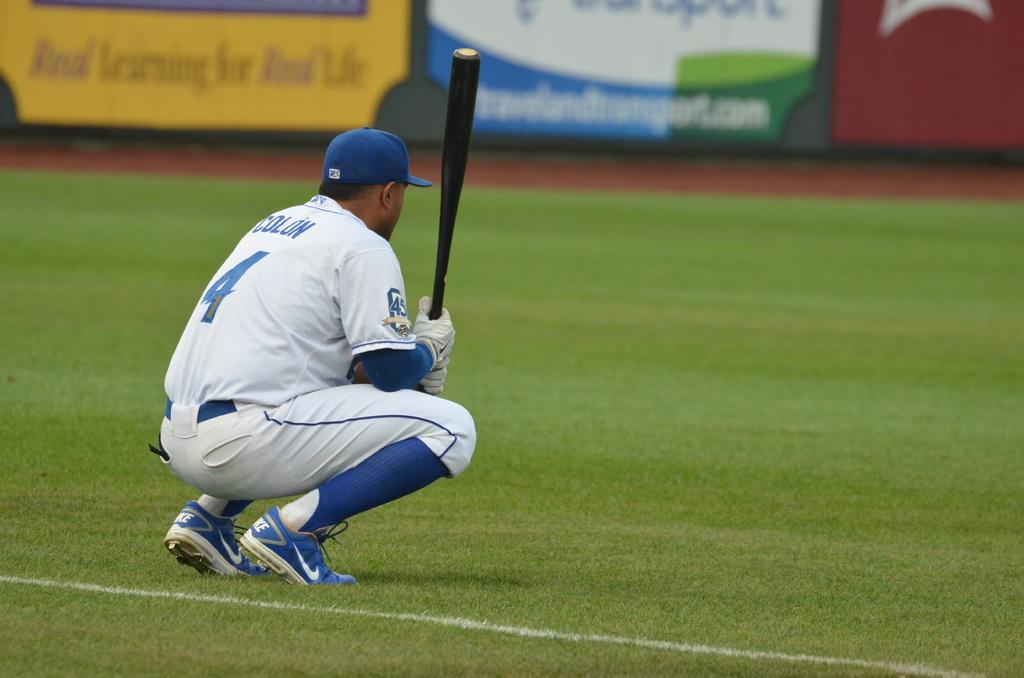<image>
Give a short and clear explanation of the subsequent image. a baseball player number 4 squatting down holding the bat 